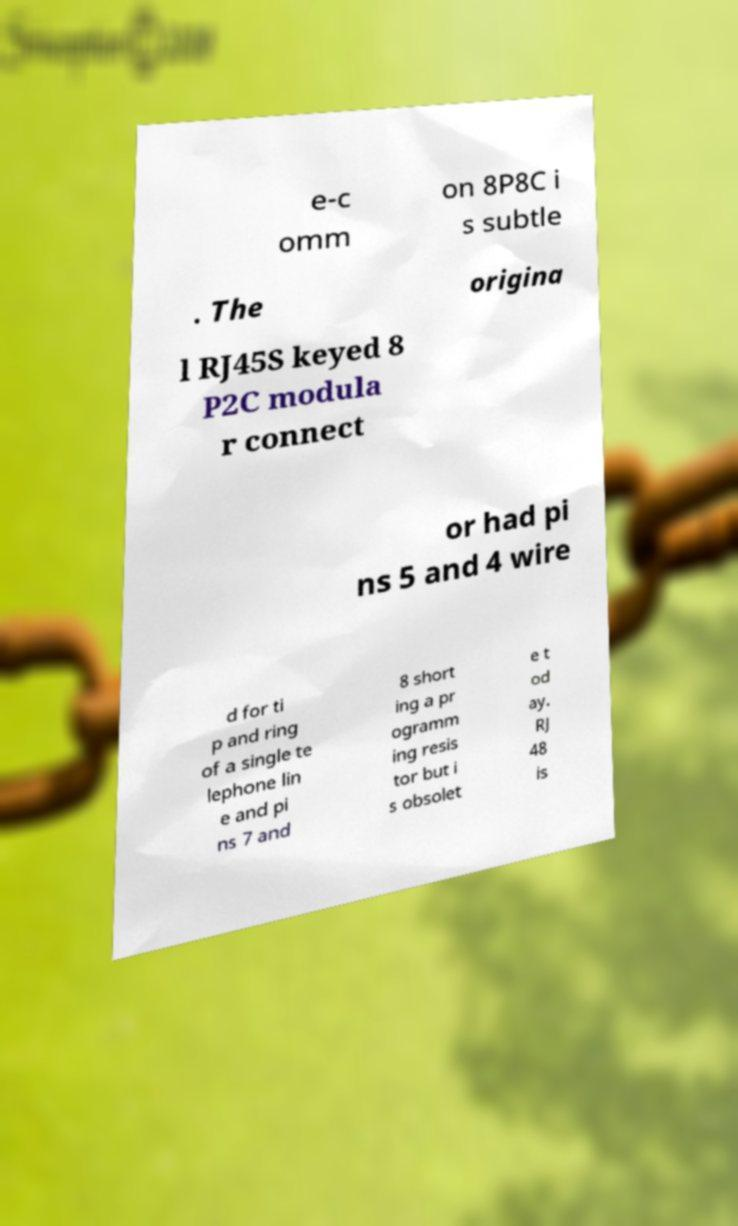For documentation purposes, I need the text within this image transcribed. Could you provide that? e-c omm on 8P8C i s subtle . The origina l RJ45S keyed 8 P2C modula r connect or had pi ns 5 and 4 wire d for ti p and ring of a single te lephone lin e and pi ns 7 and 8 short ing a pr ogramm ing resis tor but i s obsolet e t od ay. RJ 48 is 